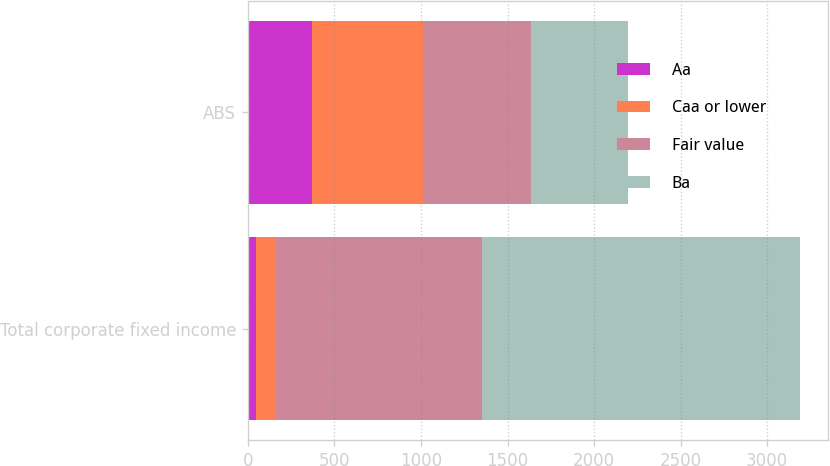Convert chart. <chart><loc_0><loc_0><loc_500><loc_500><stacked_bar_chart><ecel><fcel>Total corporate fixed income<fcel>ABS<nl><fcel>Aa<fcel>47<fcel>372<nl><fcel>Caa or lower<fcel>113<fcel>641<nl><fcel>Fair value<fcel>1195<fcel>622<nl><fcel>Ba<fcel>1836<fcel>561<nl></chart> 